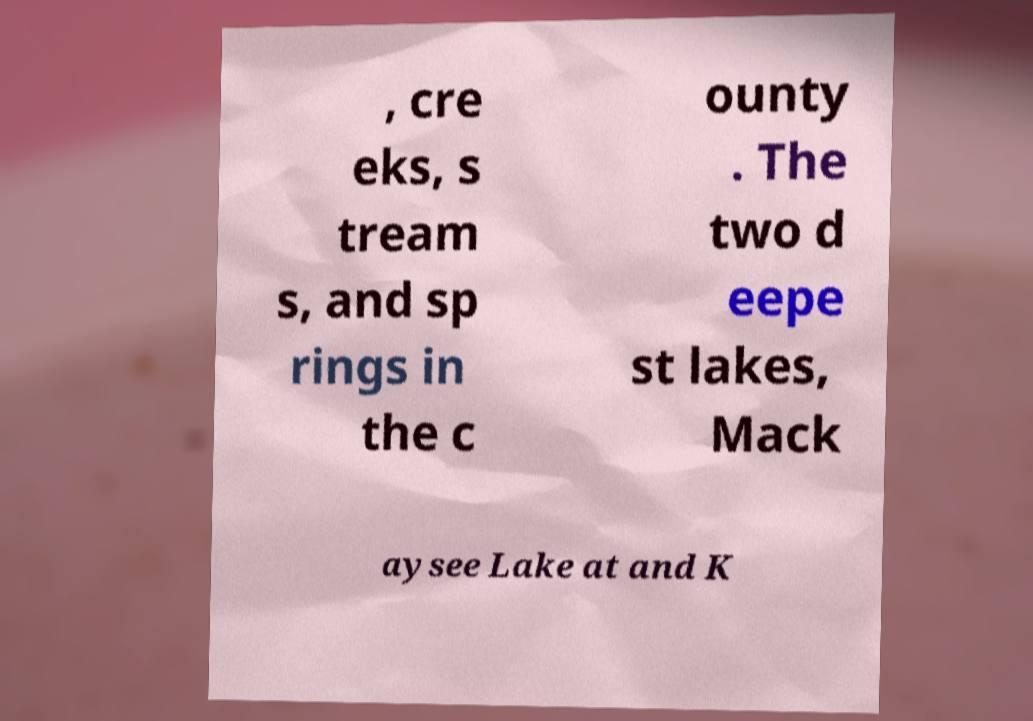Could you extract and type out the text from this image? , cre eks, s tream s, and sp rings in the c ounty . The two d eepe st lakes, Mack aysee Lake at and K 